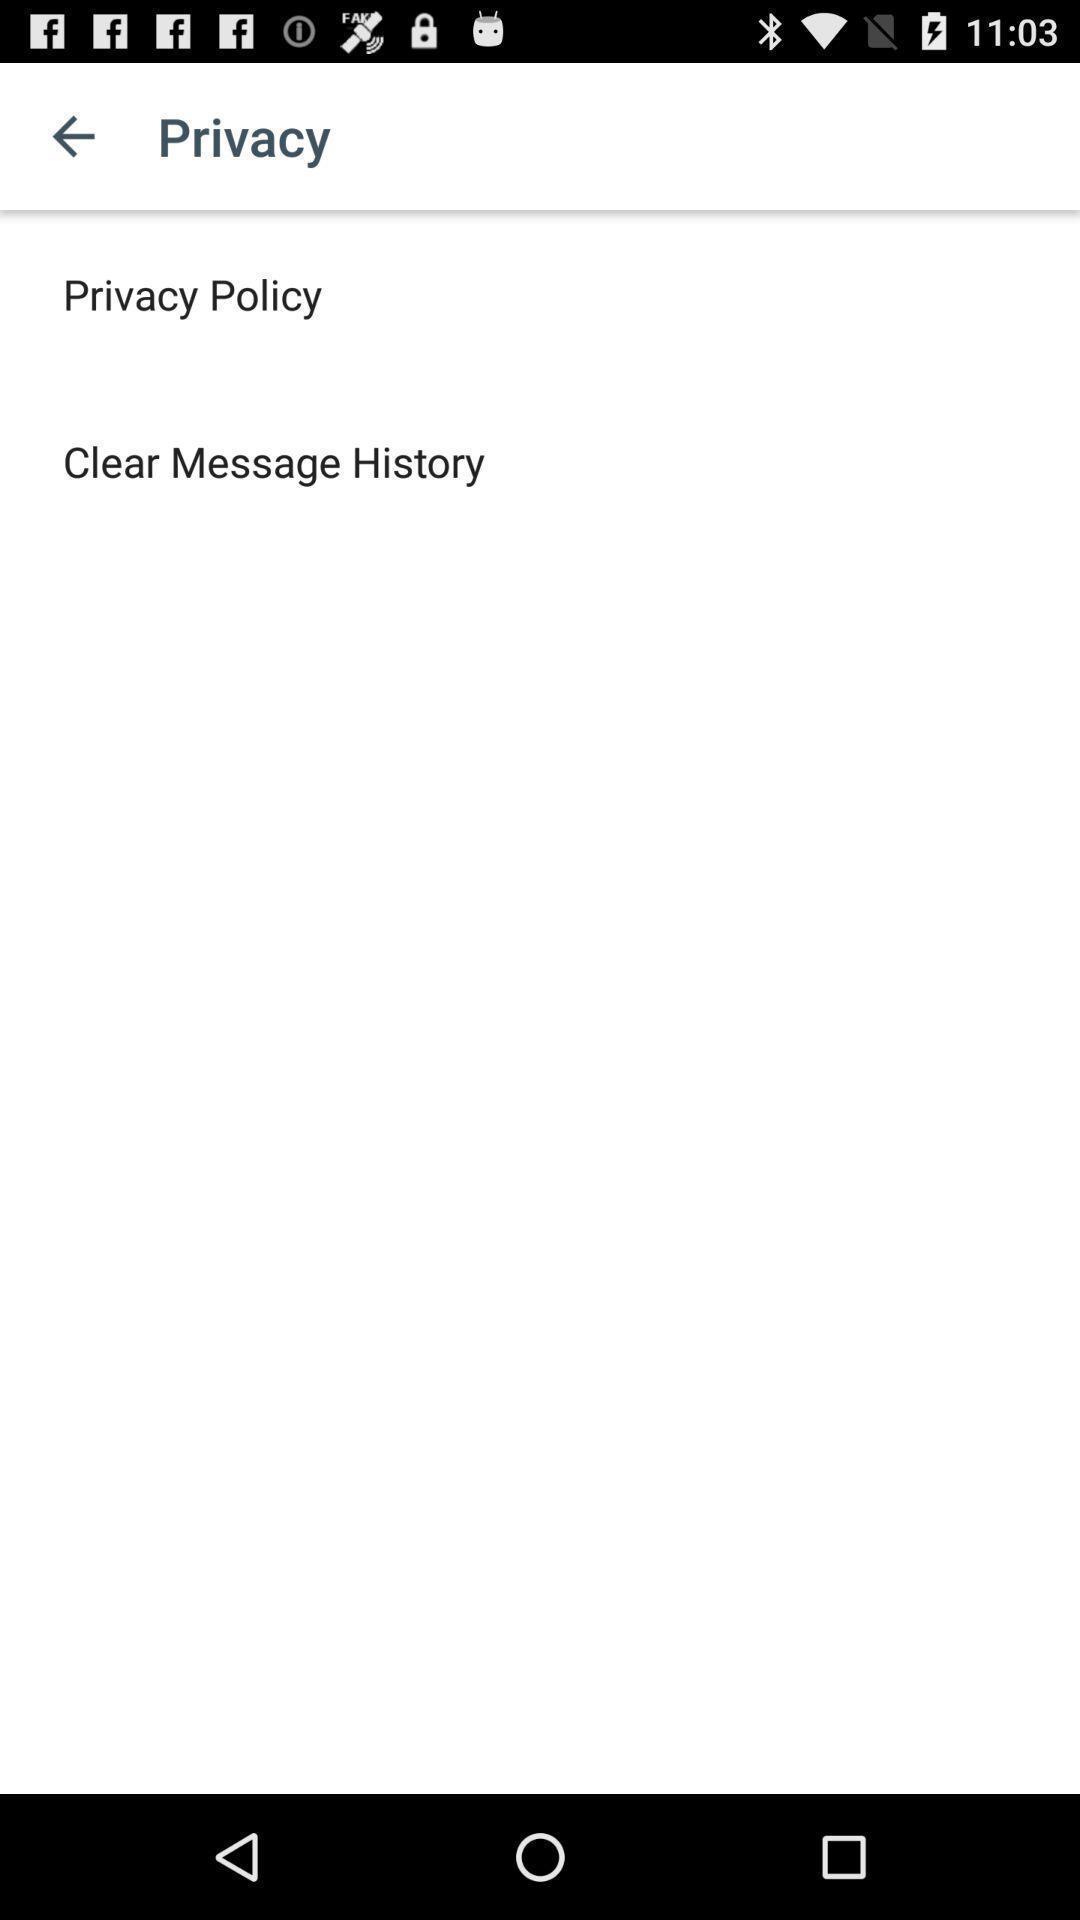Summarize the main components in this picture. Screen shows privacy page in the application. 